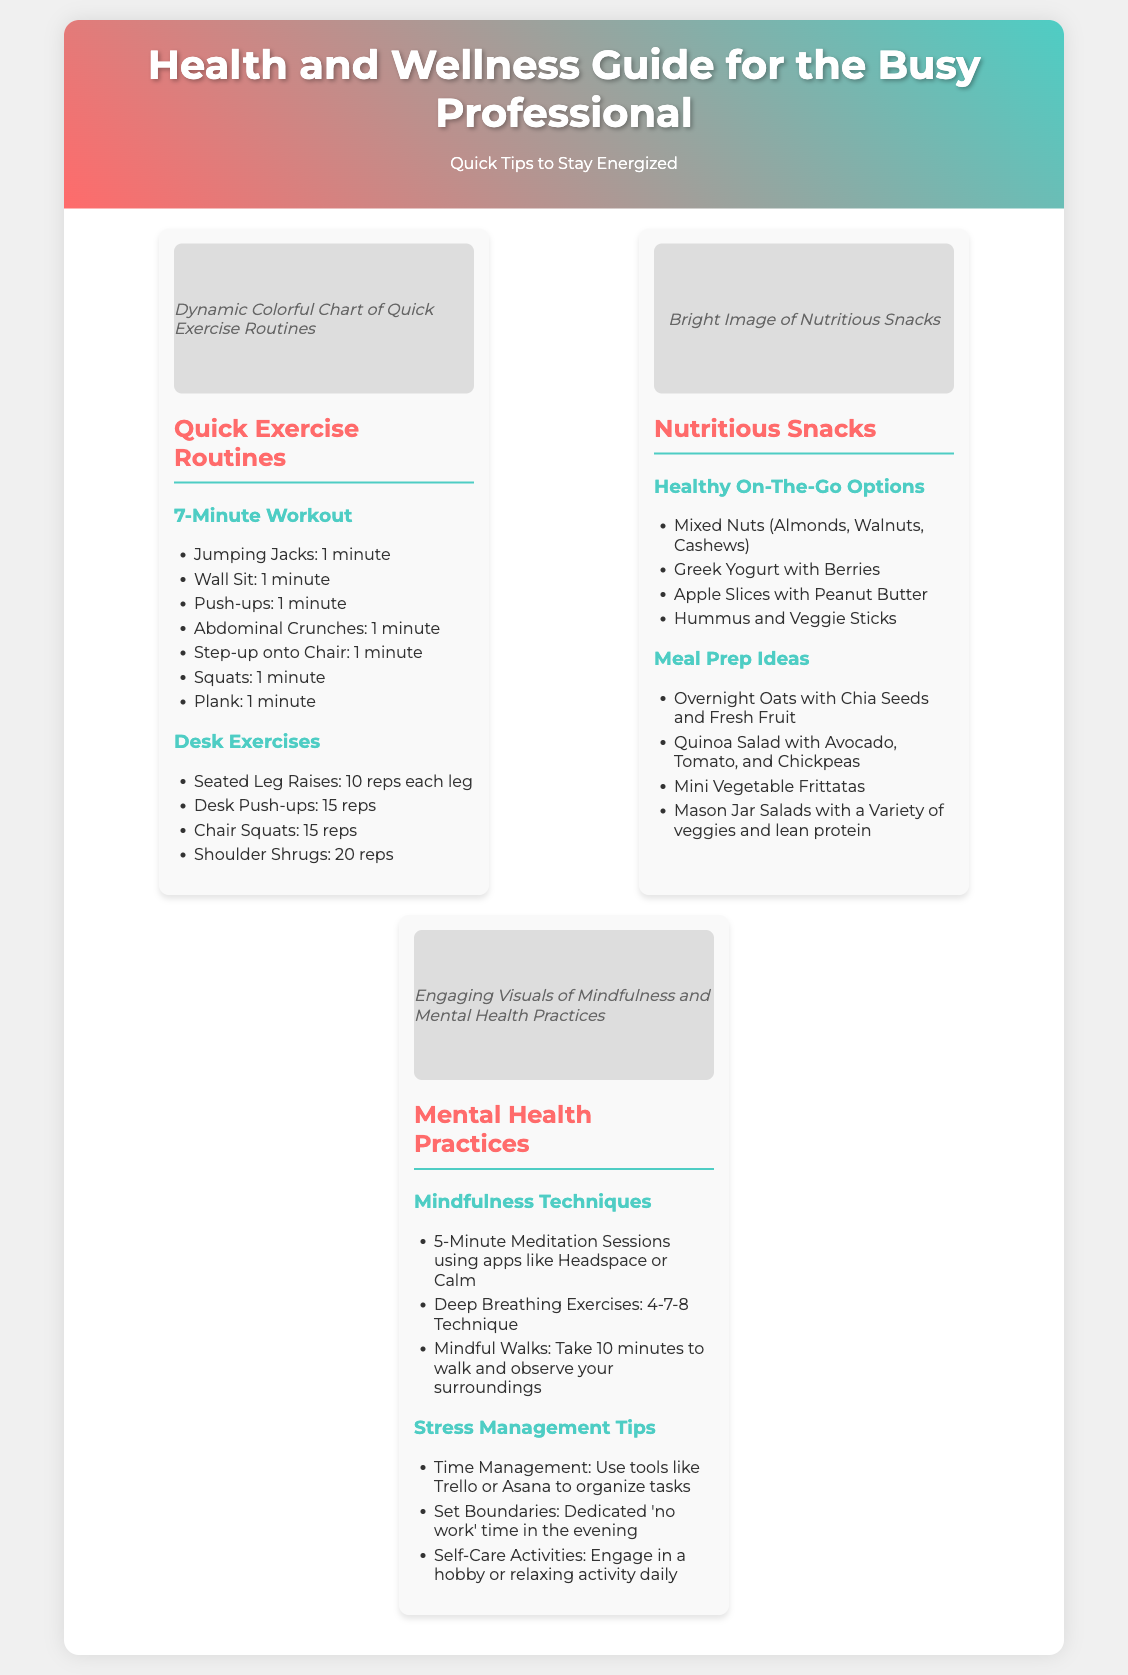What is the title of the poster? The title of the poster is prominently displayed at the top of the document.
Answer: Health and Wellness Guide for the Busy Professional How long is the suggested 7-Minute Workout? The workout is structured to be completed in a total of 7 minutes.
Answer: 7 minutes What is one item listed under Healthy On-The-Go Options? The poster includes various nutritious snacks, one of which is listed explicitly.
Answer: Mixed Nuts What mindfulness technique is recommended? The document suggests various mental health practices, one of which involves meditation.
Answer: 5-Minute Meditation Sessions How many reps are suggested for Desk Push-ups? The number of repetitions for Desk Push-ups is outlined in the exercise section.
Answer: 15 reps What is a suggested self-care activity? The poster encourages self-care as part of stress management tips, specifically mentioning an activity.
Answer: Engage in a hobby What are the colors of the header background? The background of the header features a specific color gradient.
Answer: Red and teal How many quick exercise routines are included? The section lists the types of exercises in the Quick Exercise section.
Answer: 7 routines What is the purpose of the poster? The general purpose of the document is indicated in the introductory section.
Answer: Quick Tips to Stay Energized 